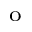Convert formula to latex. <formula><loc_0><loc_0><loc_500><loc_500>^ { o }</formula> 